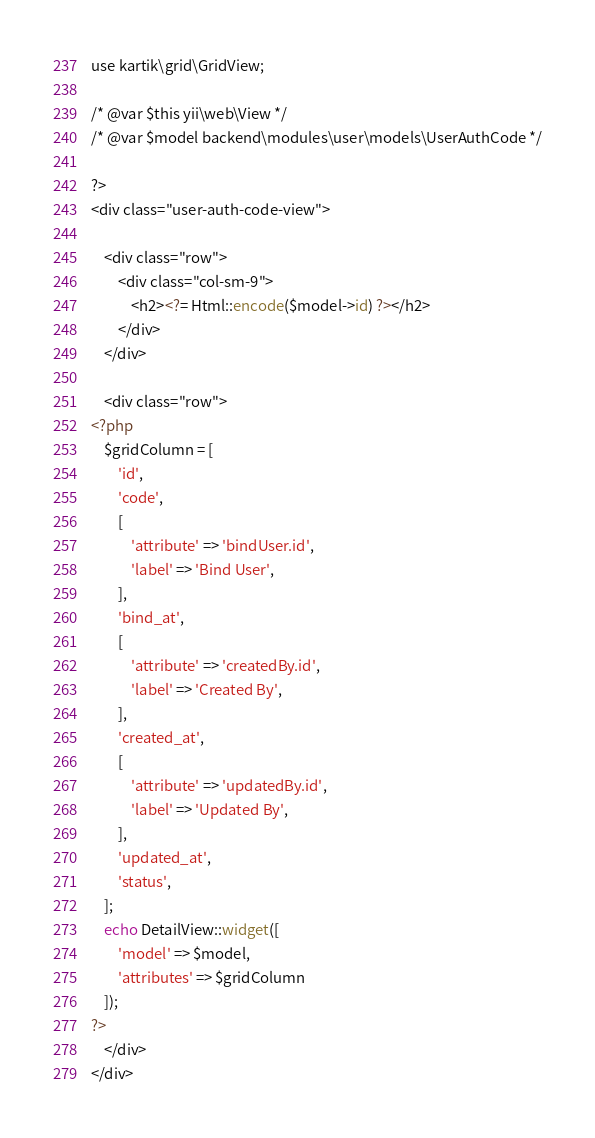<code> <loc_0><loc_0><loc_500><loc_500><_PHP_>use kartik\grid\GridView;

/* @var $this yii\web\View */
/* @var $model backend\modules\user\models\UserAuthCode */

?>
<div class="user-auth-code-view">

    <div class="row">
        <div class="col-sm-9">
            <h2><?= Html::encode($model->id) ?></h2>
        </div>
    </div>

    <div class="row">
<?php 
    $gridColumn = [
        'id',
        'code',
        [
            'attribute' => 'bindUser.id',
            'label' => 'Bind User',
        ],
        'bind_at',
        [
            'attribute' => 'createdBy.id',
            'label' => 'Created By',
        ],
        'created_at',
        [
            'attribute' => 'updatedBy.id',
            'label' => 'Updated By',
        ],
        'updated_at',
        'status',
    ];
    echo DetailView::widget([
        'model' => $model,
        'attributes' => $gridColumn
    ]); 
?>
    </div>
</div></code> 